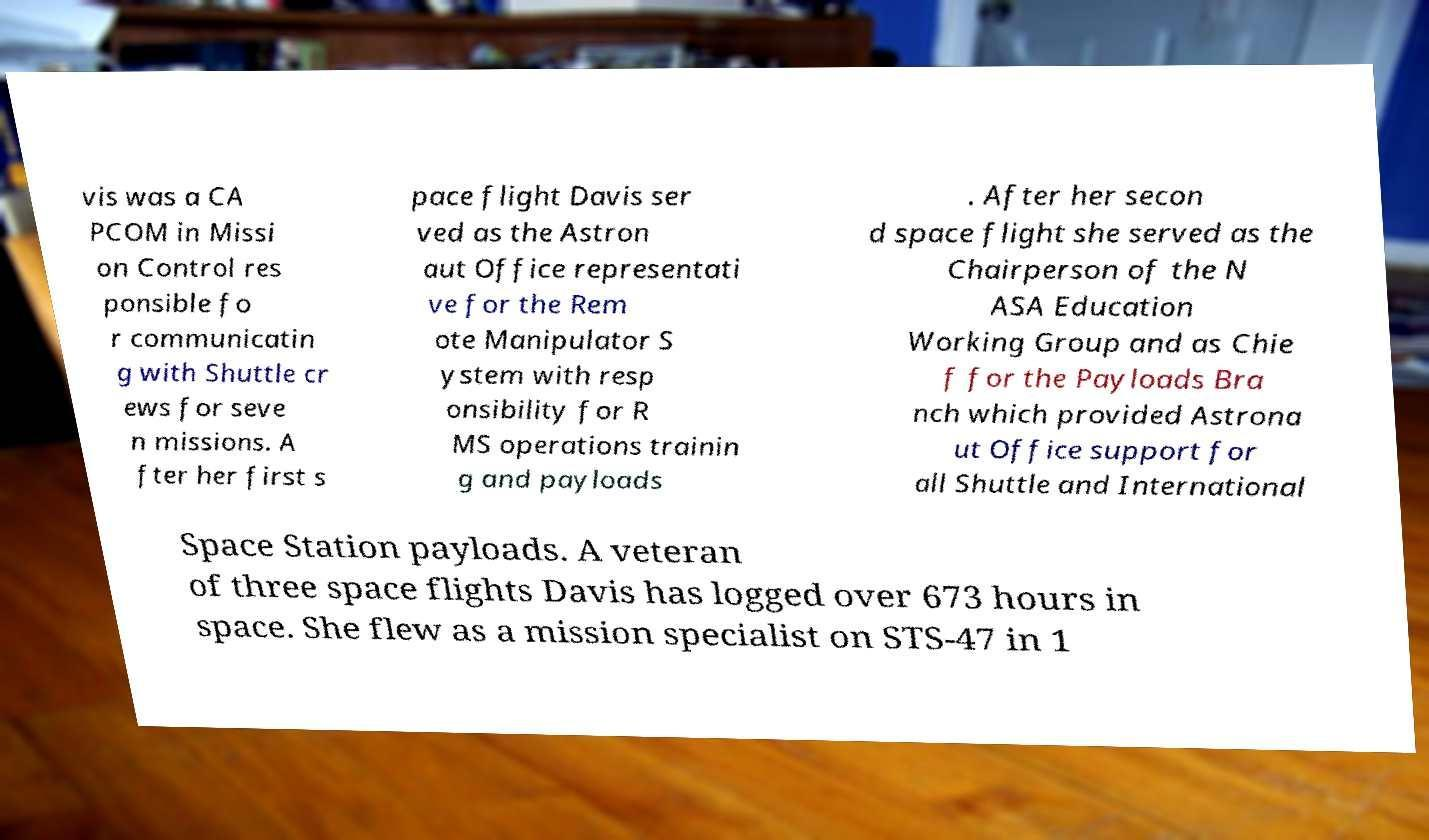What messages or text are displayed in this image? I need them in a readable, typed format. vis was a CA PCOM in Missi on Control res ponsible fo r communicatin g with Shuttle cr ews for seve n missions. A fter her first s pace flight Davis ser ved as the Astron aut Office representati ve for the Rem ote Manipulator S ystem with resp onsibility for R MS operations trainin g and payloads . After her secon d space flight she served as the Chairperson of the N ASA Education Working Group and as Chie f for the Payloads Bra nch which provided Astrona ut Office support for all Shuttle and International Space Station payloads. A veteran of three space flights Davis has logged over 673 hours in space. She flew as a mission specialist on STS-47 in 1 